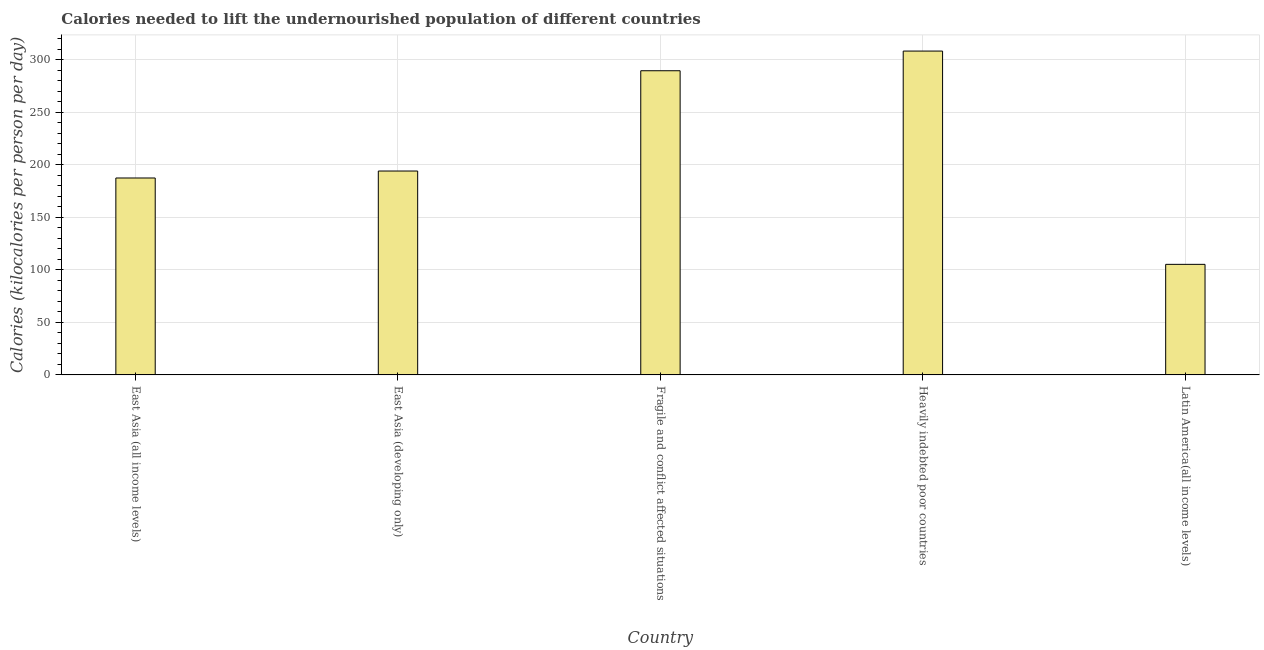Does the graph contain grids?
Ensure brevity in your answer.  Yes. What is the title of the graph?
Provide a succinct answer. Calories needed to lift the undernourished population of different countries. What is the label or title of the Y-axis?
Offer a very short reply. Calories (kilocalories per person per day). What is the depth of food deficit in Latin America(all income levels)?
Offer a very short reply. 105.28. Across all countries, what is the maximum depth of food deficit?
Your answer should be compact. 308.37. Across all countries, what is the minimum depth of food deficit?
Ensure brevity in your answer.  105.28. In which country was the depth of food deficit maximum?
Make the answer very short. Heavily indebted poor countries. In which country was the depth of food deficit minimum?
Make the answer very short. Latin America(all income levels). What is the sum of the depth of food deficit?
Ensure brevity in your answer.  1084.93. What is the difference between the depth of food deficit in Fragile and conflict affected situations and Heavily indebted poor countries?
Ensure brevity in your answer.  -18.74. What is the average depth of food deficit per country?
Give a very brief answer. 216.99. What is the median depth of food deficit?
Offer a terse response. 194.15. What is the ratio of the depth of food deficit in East Asia (developing only) to that in Fragile and conflict affected situations?
Provide a succinct answer. 0.67. What is the difference between the highest and the second highest depth of food deficit?
Ensure brevity in your answer.  18.74. What is the difference between the highest and the lowest depth of food deficit?
Provide a succinct answer. 203.09. In how many countries, is the depth of food deficit greater than the average depth of food deficit taken over all countries?
Provide a short and direct response. 2. Are all the bars in the graph horizontal?
Make the answer very short. No. How many countries are there in the graph?
Offer a very short reply. 5. What is the Calories (kilocalories per person per day) in East Asia (all income levels)?
Provide a short and direct response. 187.51. What is the Calories (kilocalories per person per day) of East Asia (developing only)?
Make the answer very short. 194.15. What is the Calories (kilocalories per person per day) in Fragile and conflict affected situations?
Ensure brevity in your answer.  289.63. What is the Calories (kilocalories per person per day) in Heavily indebted poor countries?
Offer a very short reply. 308.37. What is the Calories (kilocalories per person per day) in Latin America(all income levels)?
Your answer should be very brief. 105.28. What is the difference between the Calories (kilocalories per person per day) in East Asia (all income levels) and East Asia (developing only)?
Your response must be concise. -6.64. What is the difference between the Calories (kilocalories per person per day) in East Asia (all income levels) and Fragile and conflict affected situations?
Your answer should be compact. -102.12. What is the difference between the Calories (kilocalories per person per day) in East Asia (all income levels) and Heavily indebted poor countries?
Provide a short and direct response. -120.86. What is the difference between the Calories (kilocalories per person per day) in East Asia (all income levels) and Latin America(all income levels)?
Your response must be concise. 82.23. What is the difference between the Calories (kilocalories per person per day) in East Asia (developing only) and Fragile and conflict affected situations?
Your answer should be compact. -95.48. What is the difference between the Calories (kilocalories per person per day) in East Asia (developing only) and Heavily indebted poor countries?
Offer a terse response. -114.22. What is the difference between the Calories (kilocalories per person per day) in East Asia (developing only) and Latin America(all income levels)?
Offer a very short reply. 88.87. What is the difference between the Calories (kilocalories per person per day) in Fragile and conflict affected situations and Heavily indebted poor countries?
Keep it short and to the point. -18.74. What is the difference between the Calories (kilocalories per person per day) in Fragile and conflict affected situations and Latin America(all income levels)?
Offer a terse response. 184.35. What is the difference between the Calories (kilocalories per person per day) in Heavily indebted poor countries and Latin America(all income levels)?
Ensure brevity in your answer.  203.09. What is the ratio of the Calories (kilocalories per person per day) in East Asia (all income levels) to that in Fragile and conflict affected situations?
Provide a succinct answer. 0.65. What is the ratio of the Calories (kilocalories per person per day) in East Asia (all income levels) to that in Heavily indebted poor countries?
Offer a very short reply. 0.61. What is the ratio of the Calories (kilocalories per person per day) in East Asia (all income levels) to that in Latin America(all income levels)?
Your answer should be very brief. 1.78. What is the ratio of the Calories (kilocalories per person per day) in East Asia (developing only) to that in Fragile and conflict affected situations?
Your answer should be compact. 0.67. What is the ratio of the Calories (kilocalories per person per day) in East Asia (developing only) to that in Heavily indebted poor countries?
Your answer should be very brief. 0.63. What is the ratio of the Calories (kilocalories per person per day) in East Asia (developing only) to that in Latin America(all income levels)?
Provide a succinct answer. 1.84. What is the ratio of the Calories (kilocalories per person per day) in Fragile and conflict affected situations to that in Heavily indebted poor countries?
Make the answer very short. 0.94. What is the ratio of the Calories (kilocalories per person per day) in Fragile and conflict affected situations to that in Latin America(all income levels)?
Ensure brevity in your answer.  2.75. What is the ratio of the Calories (kilocalories per person per day) in Heavily indebted poor countries to that in Latin America(all income levels)?
Provide a succinct answer. 2.93. 